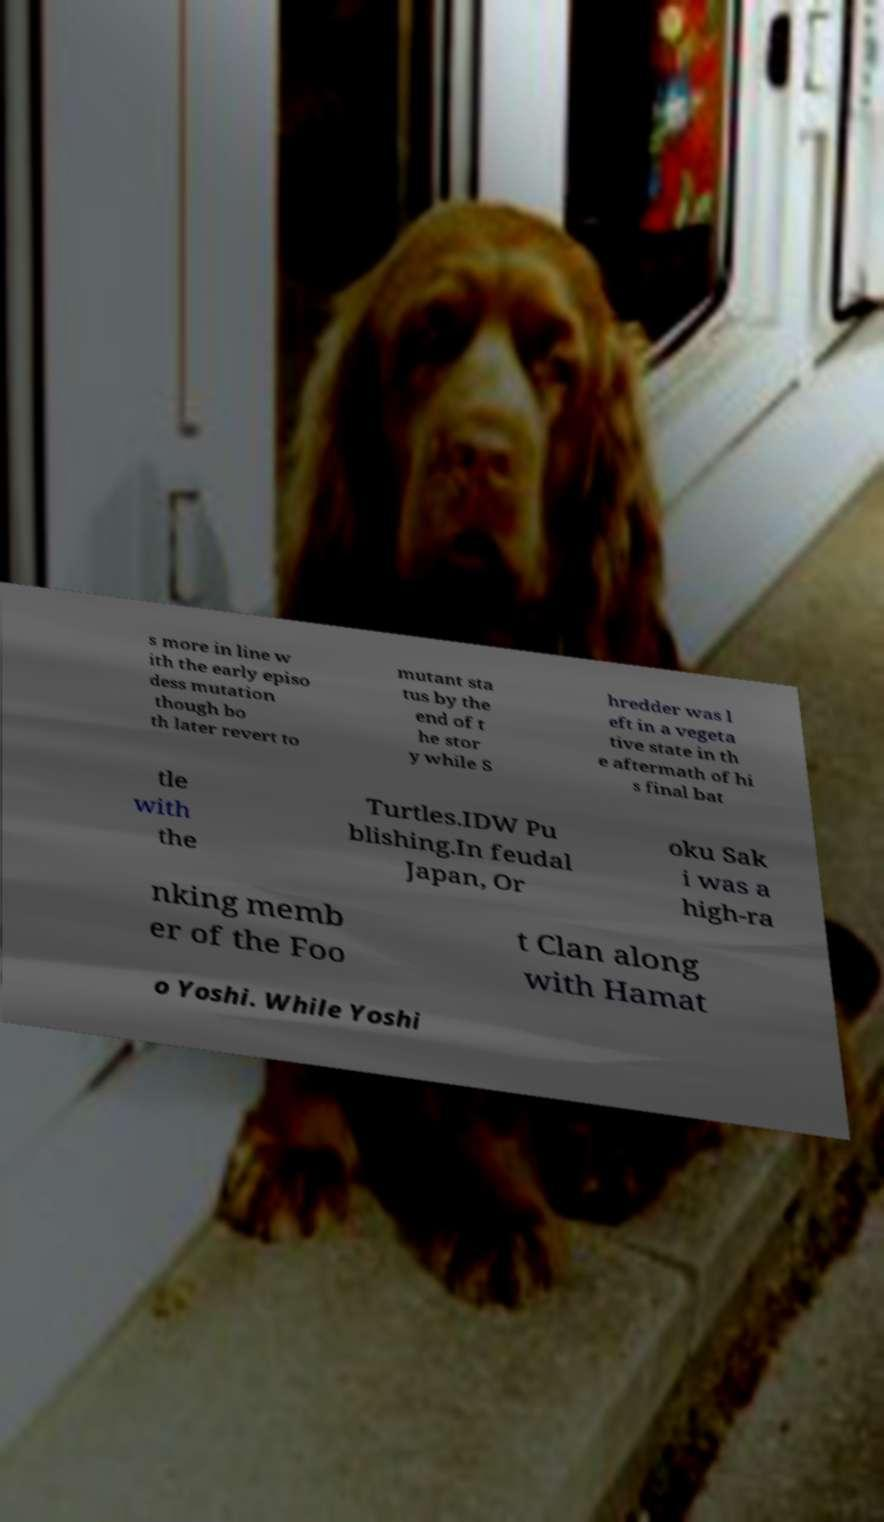Could you assist in decoding the text presented in this image and type it out clearly? s more in line w ith the early episo dess mutation though bo th later revert to mutant sta tus by the end of t he stor y while S hredder was l eft in a vegeta tive state in th e aftermath of hi s final bat tle with the Turtles.IDW Pu blishing.In feudal Japan, Or oku Sak i was a high-ra nking memb er of the Foo t Clan along with Hamat o Yoshi. While Yoshi 